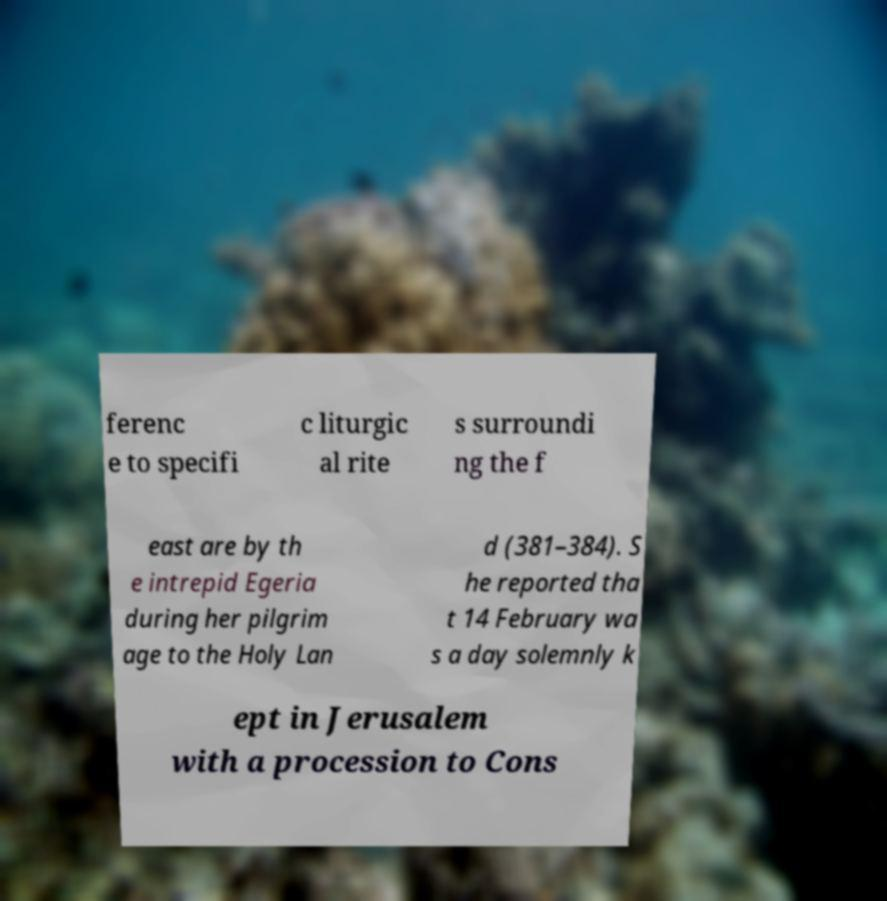Could you assist in decoding the text presented in this image and type it out clearly? ferenc e to specifi c liturgic al rite s surroundi ng the f east are by th e intrepid Egeria during her pilgrim age to the Holy Lan d (381–384). S he reported tha t 14 February wa s a day solemnly k ept in Jerusalem with a procession to Cons 